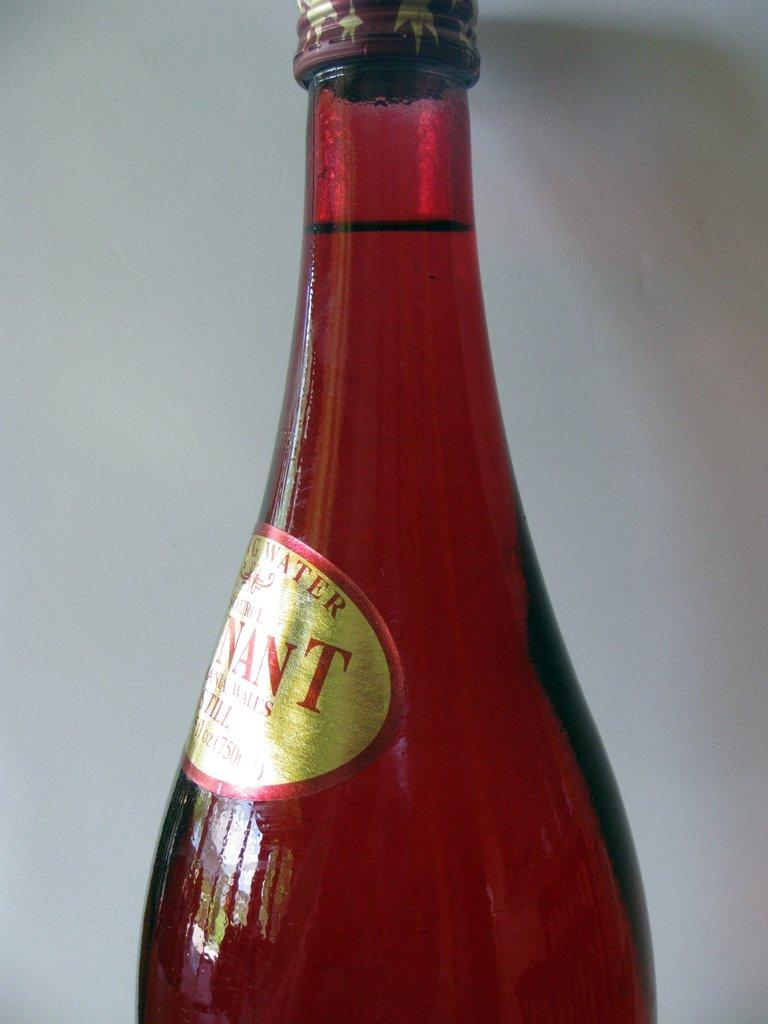<image>
Present a compact description of the photo's key features. The top of a red glass bottle with the letters NANT visibler. 